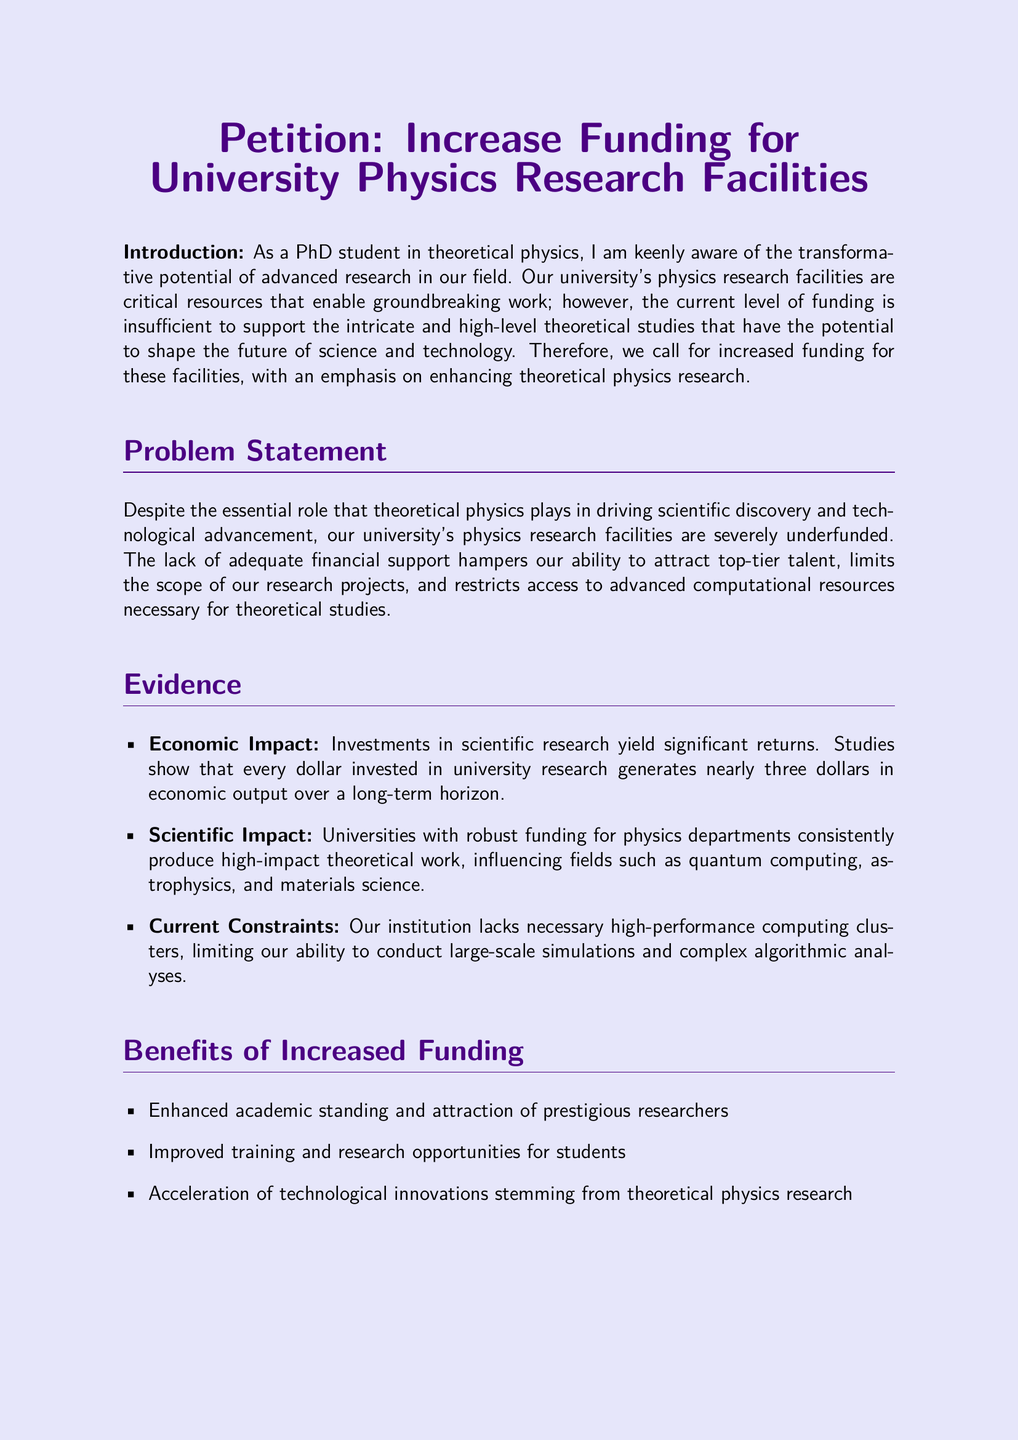What is the title of the petition? The title of the petition is prominently displayed at the top of the document.
Answer: Increase Funding for University Physics Research Facilities What is emphasized in the funding increase? The petition specifies what aspect of research the funding should focus on.
Answer: Theoretical Studies What is the first point mentioned under Evidence? The document lists various points under the Evidence section, starting with the economic impact.
Answer: Economic Impact How many benefits of increased funding are listed? The document outlines specific benefits, indicating a number of items.
Answer: Three What type of stakeholders does the call to action mention? The petition includes a diverse group of individuals it addresses in the call to action section.
Answer: University administrators, government officials, and private stakeholders What does the introduction of the petition mention about funding? The introduction sets the stage for the petition by highlighting the issue of funding.
Answer: Insufficient Who supported the preparation of this petition? The last section cites groups that back the petition's preparation, indicating broad support.
Answer: Students, faculty, and researchers What aspect does improved funding aim to accelerate? Among the listed benefits, one is specifically related to technological advancements.
Answer: Technological innovations Where should individuals sign the petition? The document provides a designated area for signatures and names, indicating where participants should take action.
Answer: Below the call to action 